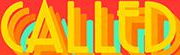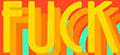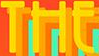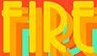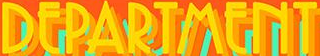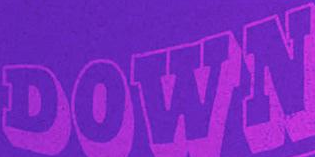Transcribe the words shown in these images in order, separated by a semicolon. CALLED; FUCK; THE; FIRE; DEPARTMENT; DOWN 